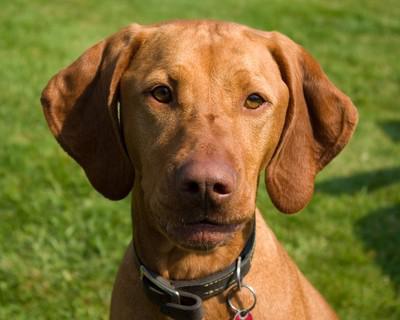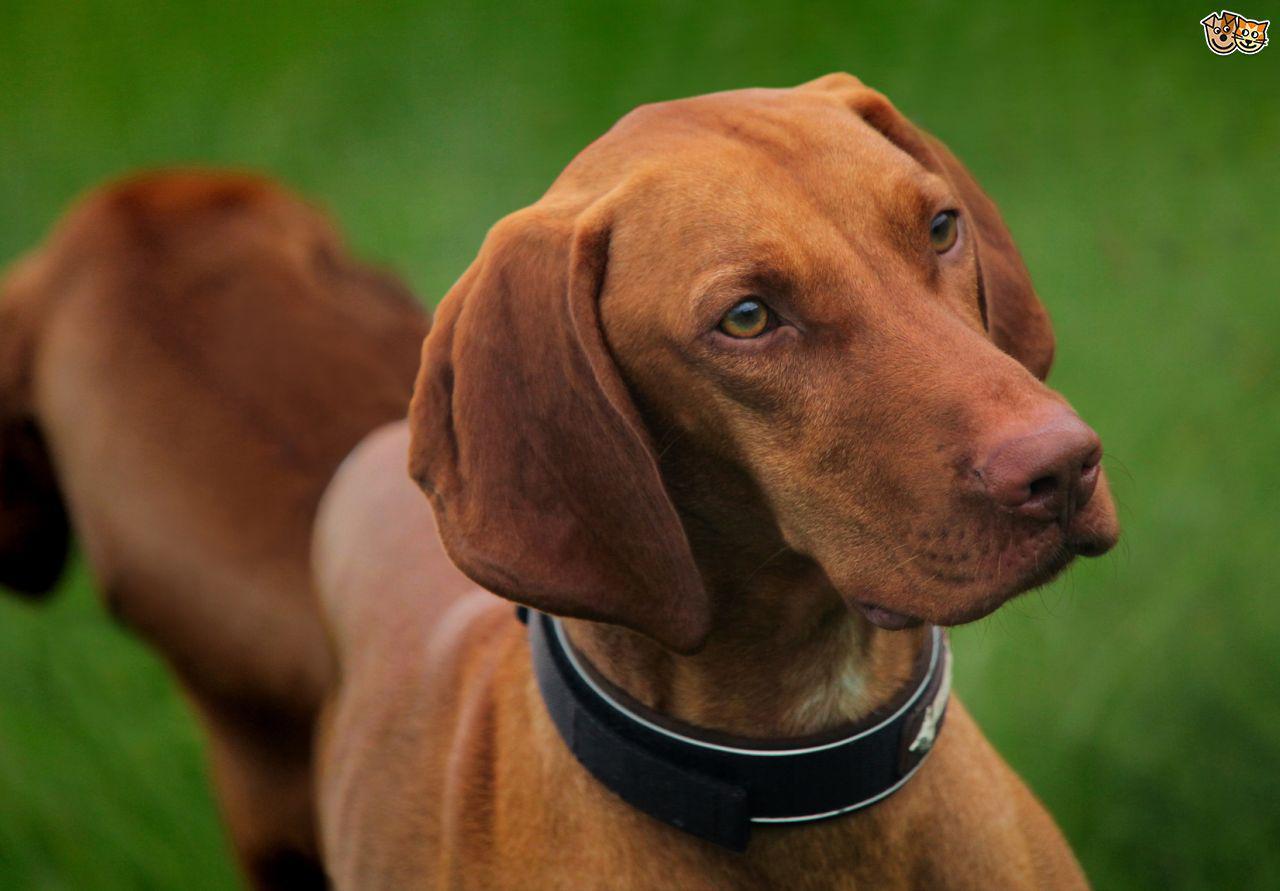The first image is the image on the left, the second image is the image on the right. Considering the images on both sides, is "In at least one image you can see a single brown dog looking straight forward who is wearing a coller." valid? Answer yes or no. Yes. The first image is the image on the left, the second image is the image on the right. Assess this claim about the two images: "At least two dogs are wearing black collars and at least half of the dogs are looking upward.". Correct or not? Answer yes or no. Yes. 